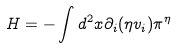Convert formula to latex. <formula><loc_0><loc_0><loc_500><loc_500>H = - \int d ^ { 2 } x \partial _ { i } ( \eta v _ { i } ) \pi ^ { \eta }</formula> 